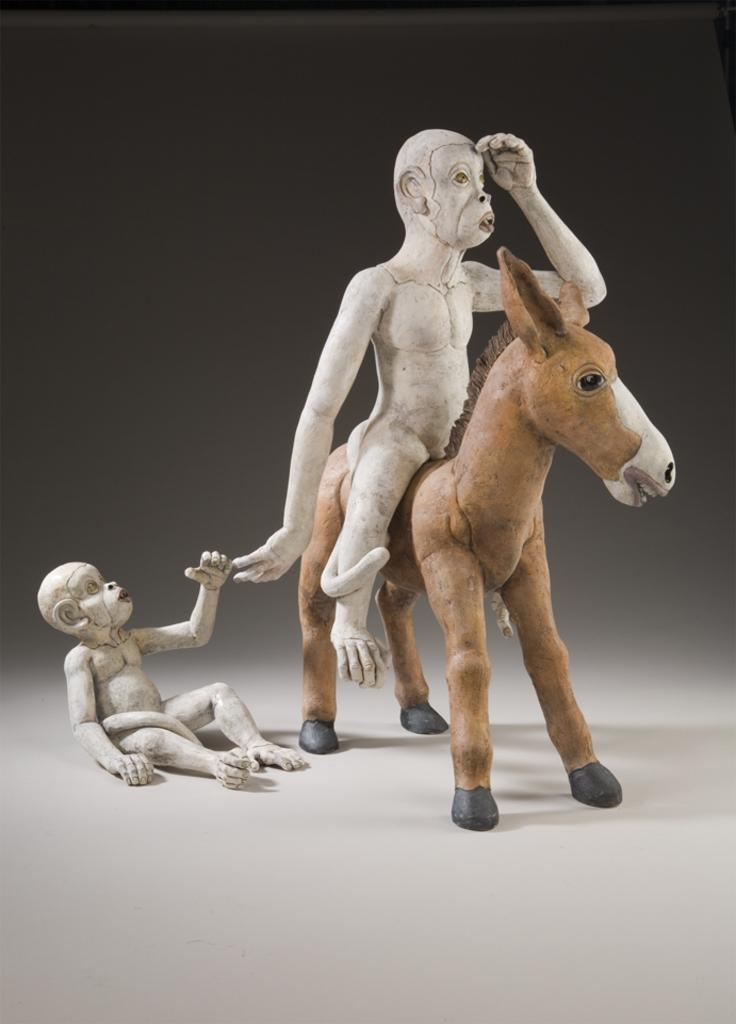What objects are present in the image? There are toys in the image. What is the color of the surface on which the toys are placed? The toys are on a white surface. What can be observed about the background of the image? The background of the image is dark. What type of vacation is being planned by the toys in the image? There is no indication in the image that the toys are planning a vacation, as they are inanimate objects and cannot plan or participate in vacations. 